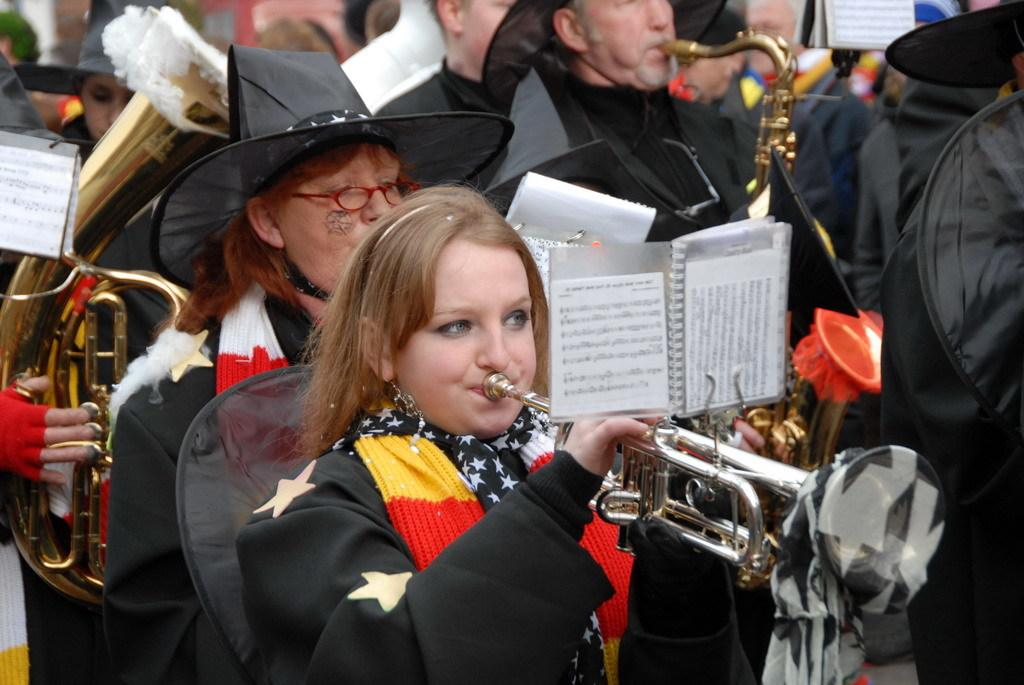How many people are in the image? There are many people in the image. What are the people in the front wearing? Some people in the front are wearing black coats. What are these people in the front doing? These people in the front are blowing trumpets. What type of net is being used to catch fish in the image? There is no net or fish present in the image; it features a group of people with some wearing black coats and blowing trumpets. 